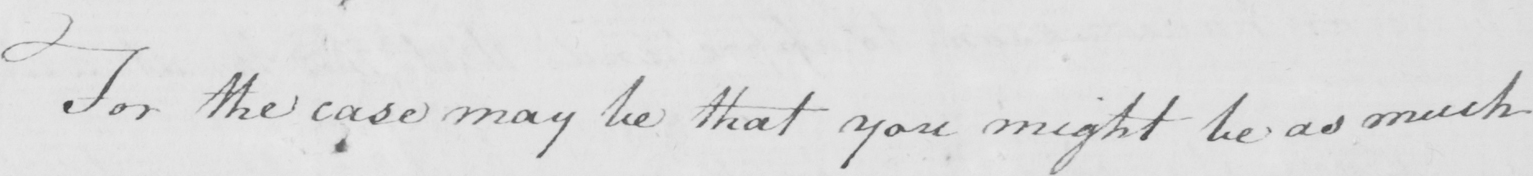Transcribe the text shown in this historical manuscript line. For the case may be that you might be as much 